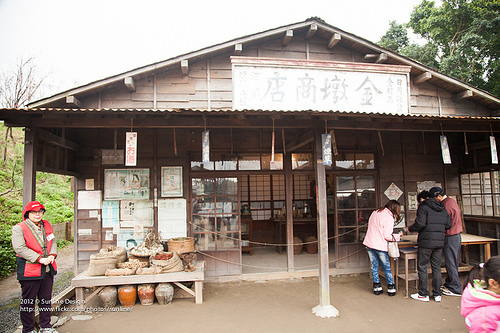<image>
Can you confirm if the vegetables is on the floor? No. The vegetables is not positioned on the floor. They may be near each other, but the vegetables is not supported by or resting on top of the floor. 